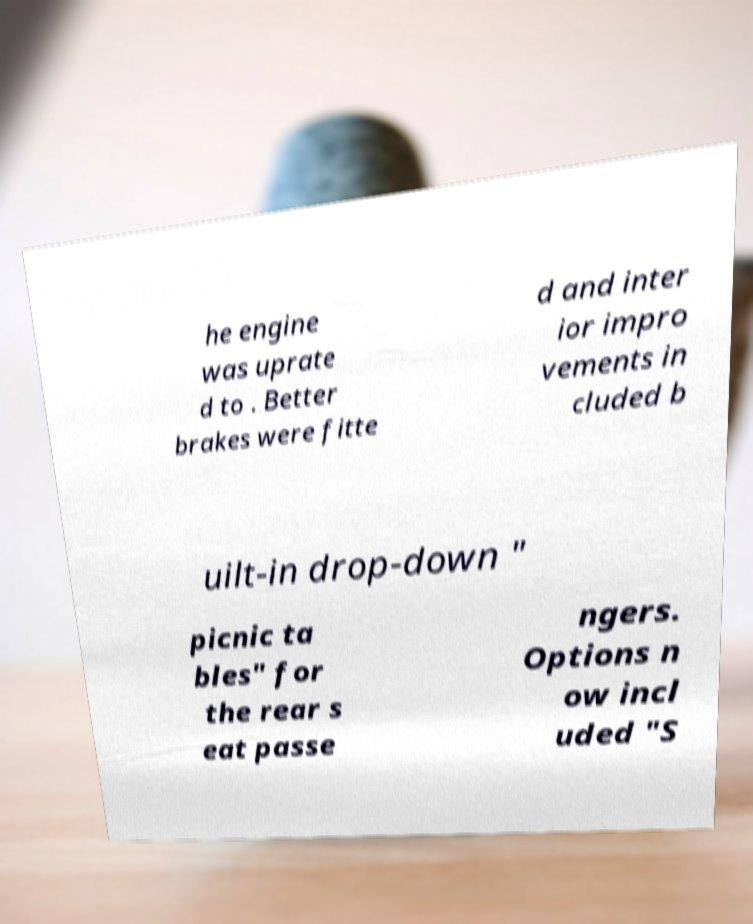Please identify and transcribe the text found in this image. he engine was uprate d to . Better brakes were fitte d and inter ior impro vements in cluded b uilt-in drop-down " picnic ta bles" for the rear s eat passe ngers. Options n ow incl uded "S 